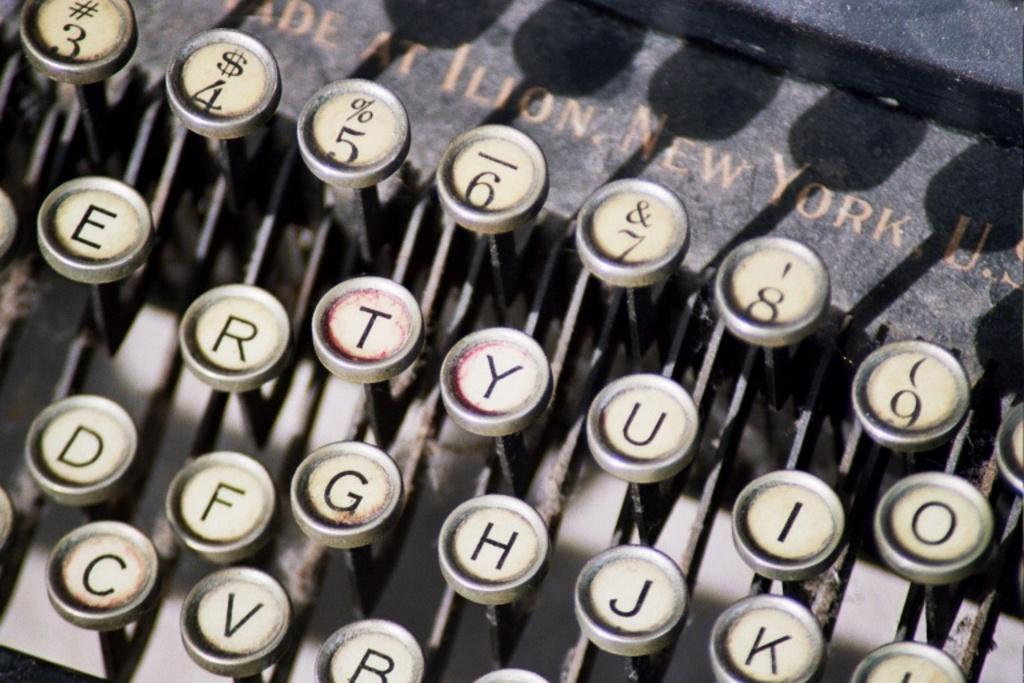<image>
Write a terse but informative summary of the picture. a typewriter with the number 3 on it 